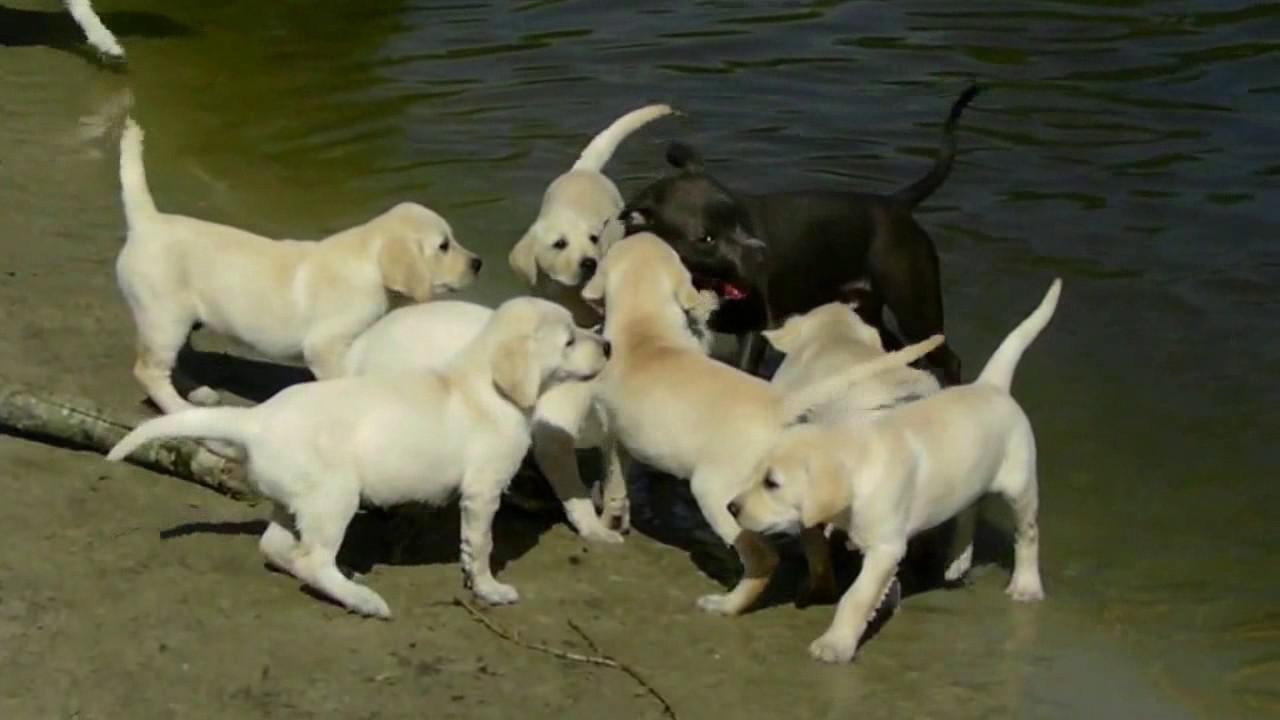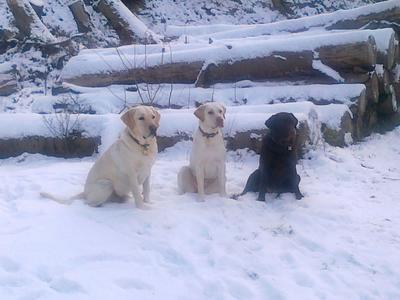The first image is the image on the left, the second image is the image on the right. Evaluate the accuracy of this statement regarding the images: "An image shows dogs in a wet area and includes one black dog with at least six """"blond"""" ones.". Is it true? Answer yes or no. Yes. The first image is the image on the left, the second image is the image on the right. Given the left and right images, does the statement "There's no more than three dogs in the right image." hold true? Answer yes or no. Yes. 